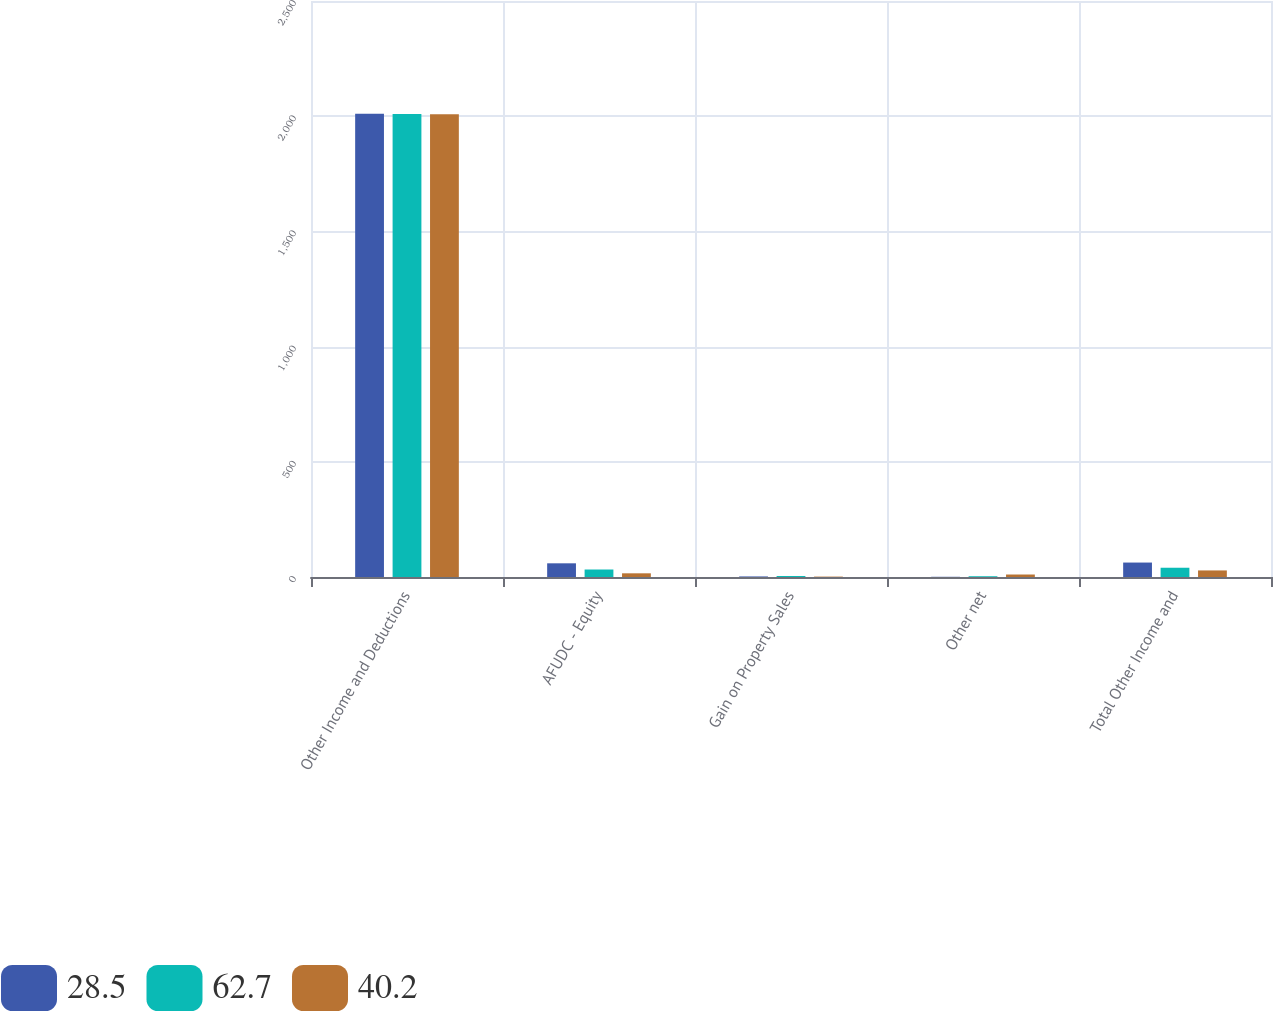Convert chart. <chart><loc_0><loc_0><loc_500><loc_500><stacked_bar_chart><ecel><fcel>Other Income and Deductions<fcel>AFUDC - Equity<fcel>Gain on Property Sales<fcel>Other net<fcel>Total Other Income and<nl><fcel>28.5<fcel>2011<fcel>59.4<fcel>2.4<fcel>0.9<fcel>62.7<nl><fcel>62.7<fcel>2010<fcel>32.5<fcel>4.4<fcel>3.3<fcel>40.2<nl><fcel>40.2<fcel>2009<fcel>16<fcel>1.7<fcel>10.8<fcel>28.5<nl></chart> 